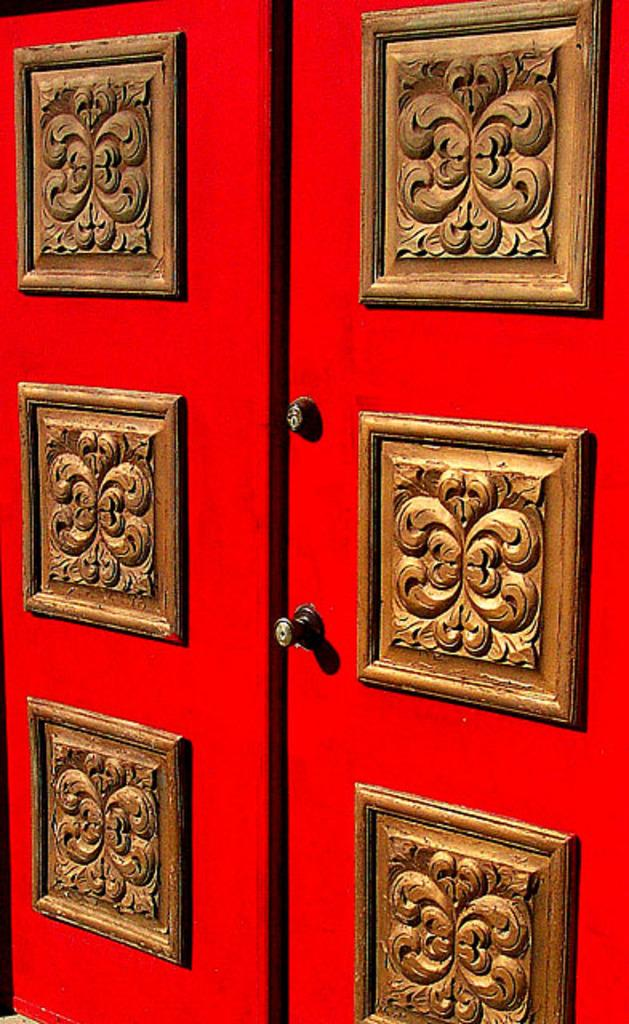What color are the doors in the image? The doors in the image are red. What material is used for the doors? The doors have a wooden sculpture on them, indicating that they are made of wood. Can you see a woman walking through the wilderness in the image? There is no woman or wilderness present in the image; it only features red doors with a wooden sculpture. Are there any insects visible on the doors in the image? There is no mention of insects in the provided facts, and therefore we cannot determine if any are present in the image. 